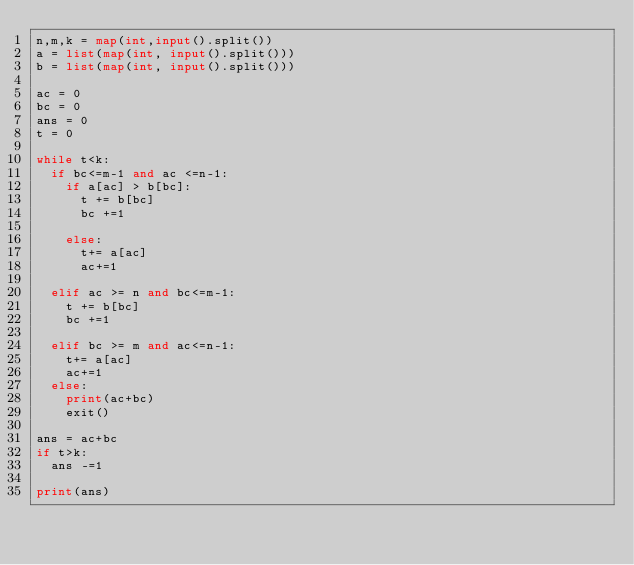Convert code to text. <code><loc_0><loc_0><loc_500><loc_500><_Python_>n,m,k = map(int,input().split())
a = list(map(int, input().split()))
b = list(map(int, input().split()))

ac = 0
bc = 0
ans = 0
t = 0

while t<k:
  if bc<=m-1 and ac <=n-1:
    if a[ac] > b[bc]:
      t += b[bc]
      bc +=1

    else:
      t+= a[ac]
      ac+=1
 
  elif ac >= n and bc<=m-1:
    t += b[bc]
    bc +=1

  elif bc >= m and ac<=n-1:
    t+= a[ac]
    ac+=1
  else:
    print(ac+bc)
    exit()

ans = ac+bc
if t>k:
  ans -=1

print(ans)</code> 